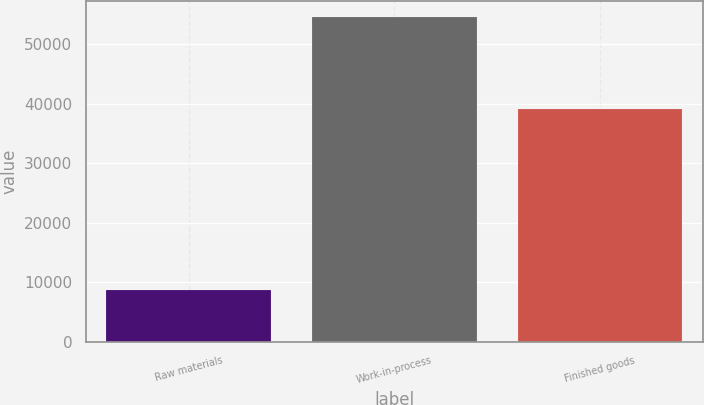Convert chart. <chart><loc_0><loc_0><loc_500><loc_500><bar_chart><fcel>Raw materials<fcel>Work-in-process<fcel>Finished goods<nl><fcel>8651<fcel>54633<fcel>39170<nl></chart> 